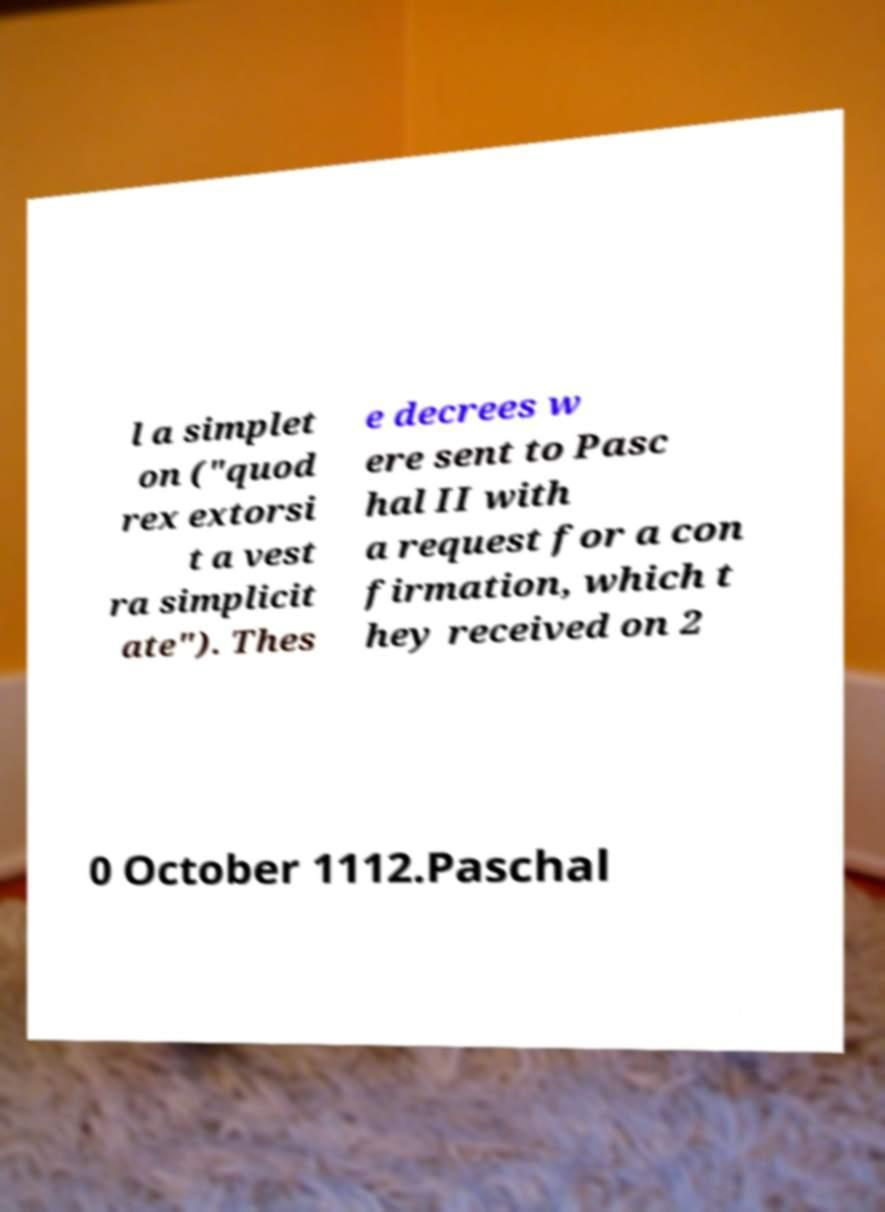Could you extract and type out the text from this image? l a simplet on ("quod rex extorsi t a vest ra simplicit ate"). Thes e decrees w ere sent to Pasc hal II with a request for a con firmation, which t hey received on 2 0 October 1112.Paschal 